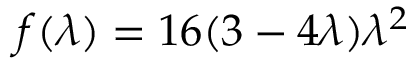<formula> <loc_0><loc_0><loc_500><loc_500>f ( \lambda ) = 1 6 ( 3 - 4 \lambda ) \lambda ^ { 2 }</formula> 